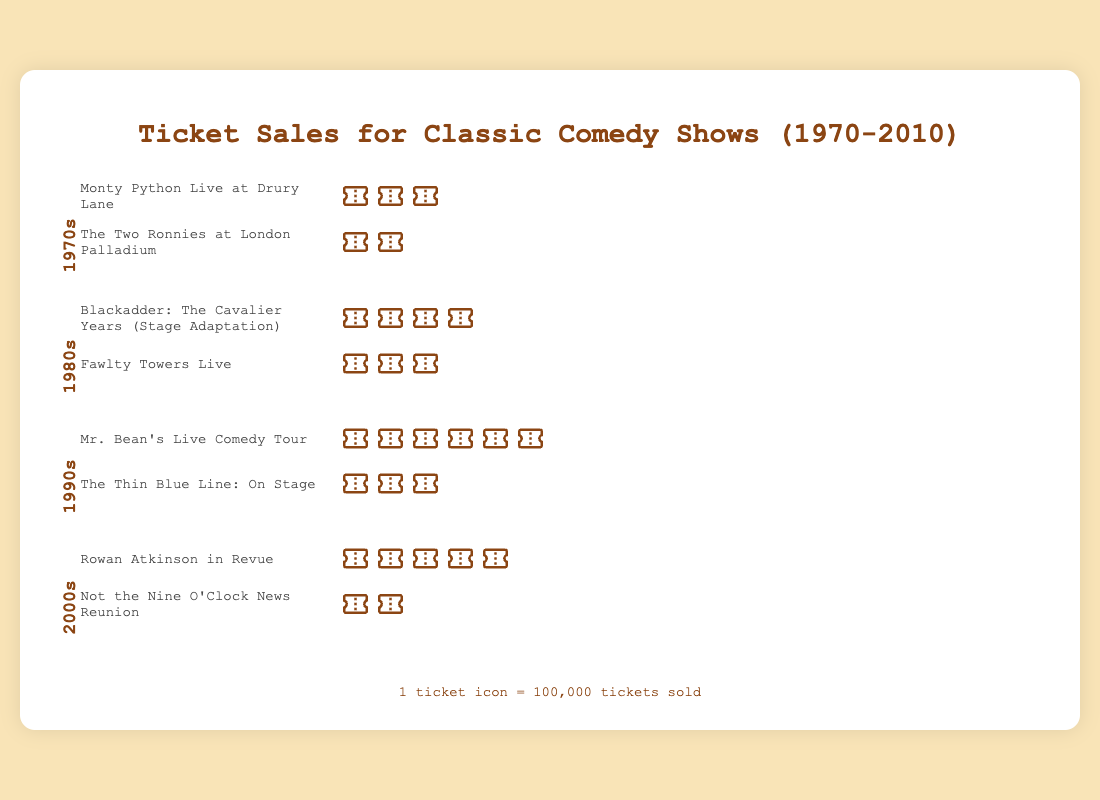What is the title of the plot? The title is prominently displayed at the top center of the plot, written in a larger and bold font. It reads "Ticket Sales for Classic Comedy Shows (1970-2010)".
Answer: Ticket Sales for Classic Comedy Shows (1970-2010) How many tickets were sold for "Monty Python Live at Drury Lane" in the 1970s? Each ticket icon represents 100,000 tickets sold. "Monty Python Live at Drury Lane" has 3 ticket icons. Therefore, the total number of tickets sold is 3 * 100,000.
Answer: 300,000 Which show sold the most tickets during the 1990s? By looking at the number of ticket icons for each show in the 1990s section, "Mr. Bean's Live Comedy Tour" has 6 icons, more than "The Thin Blue Line: On Stage" which has 3 icons.
Answer: Mr. Bean's Live Comedy Tour What is the total number of tickets sold for shows in the 1980s? In the 1980s section, "Blackadder: The Cavalier Years (Stage Adaptation)" has 4 ticket icons and "Fawlty Towers Live" has 3 ticket icons. The total tickets sold are (4 + 3) * 100,000.
Answer: 700,000 How do ticket sales for "Rowan Atkinson in Revue" in the 2000s compare to "Mr. Bean's Live Comedy Tour" in the 1990s? "Rowan Atkinson in Revue" has 5 ticket icons, and "Mr. Bean's Live Comedy Tour" has 6 ticket icons. 5 is less than 6, indicating fewer tickets were sold for "Rowan Atkinson in Revue".
Answer: Fewer Which decade has the highest total number of tickets sold? Calculate the total tickets for each decade: 
1970s: (3 + 2) * 100,000 = 500,000 
1980s: (4 + 3) * 100,000 = 700,000 
1990s: (6 + 3) * 100,000 = 900,000 
2000s: (5 + 2) * 100,000 = 700,000 
Comparing these, the 1990s has the highest with 900,000 tickets sold.
Answer: 1990s What is the combined ticket sales for "The Two Ronnies at London Palladium" and "Not the Nine O'Clock News Reunion"? "The Two Ronnies at London Palladium" has 2 ticket icons, "Not the Nine O'Clock News Reunion" also has 2 ticket icons. Combined total is (2 + 2) * 100,000.
Answer: 400,000 How many more tickets did "Mr. Bean's Live Comedy Tour" sell compared to "The Thin Blue Line: On Stage"? "Mr. Bean's Live Comedy Tour" has 6 ticket icons while "The Thin Blue Line: On Stage" has 3. The difference is (6 - 3) * 100,000.
Answer: 300,000 